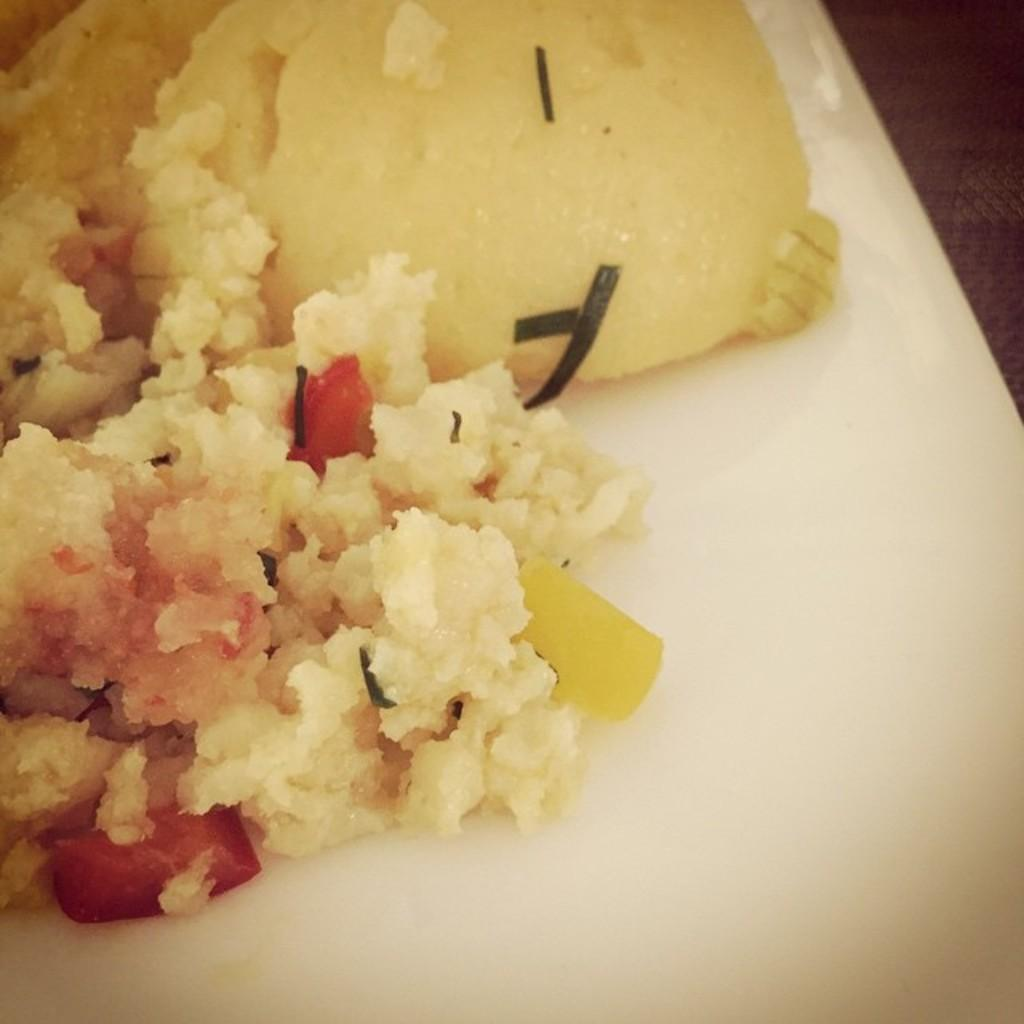What is located in the foreground of the image? There is a platter in the foreground of the image. What is on the platter? The platter contains food items. On what surface is the platter placed? The platter is on a surface. What type of trick can be seen being performed with the produce on the platter? There is no trick being performed in the image, and there is no produce mentioned. How many people are taking a trip together in the image? There is no indication of people taking a trip in the image; it features a platter with food items. 